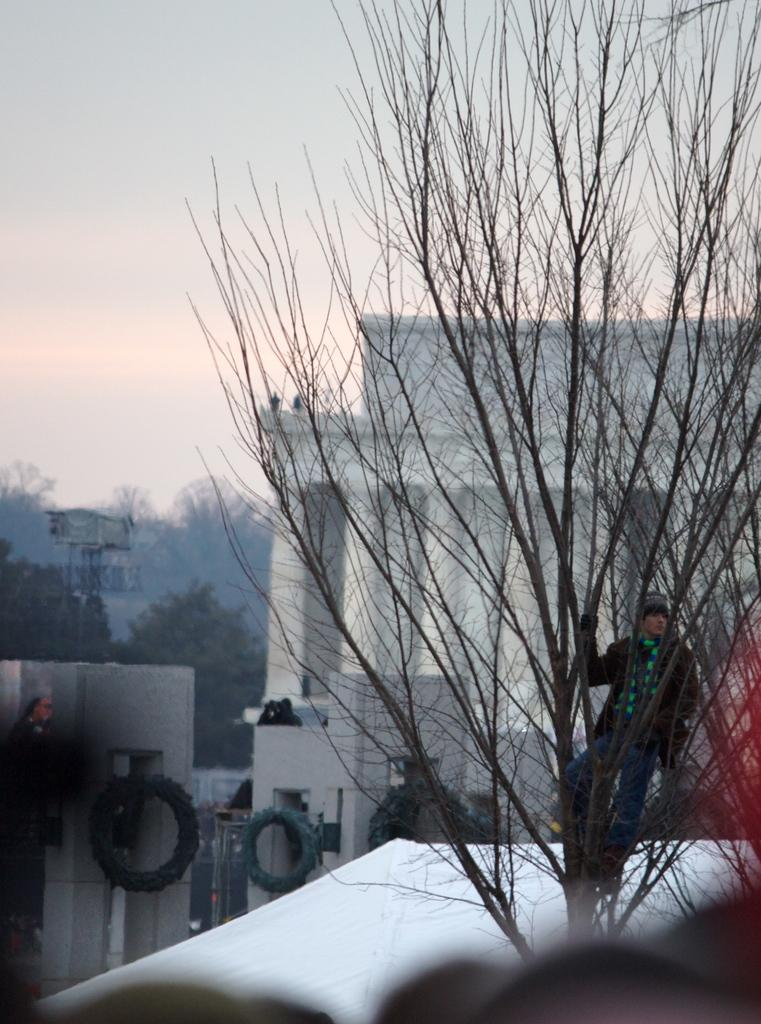What is the person in the image doing? The person is standing on a tree in the image. What type of structures can be seen in the image? There are buildings visible in the image. What other natural elements are present in the image? There are trees in the image. What objects can be seen on the ground in the image? There are tires in the image. What can be seen in the background of the image? The sky is visible in the background of the image. Where can the map be found in the image? There is no map present in the image. How many pizzas are being delivered by the person standing on the tree? There are no pizzas visible in the image, and the person is not delivering anything. 